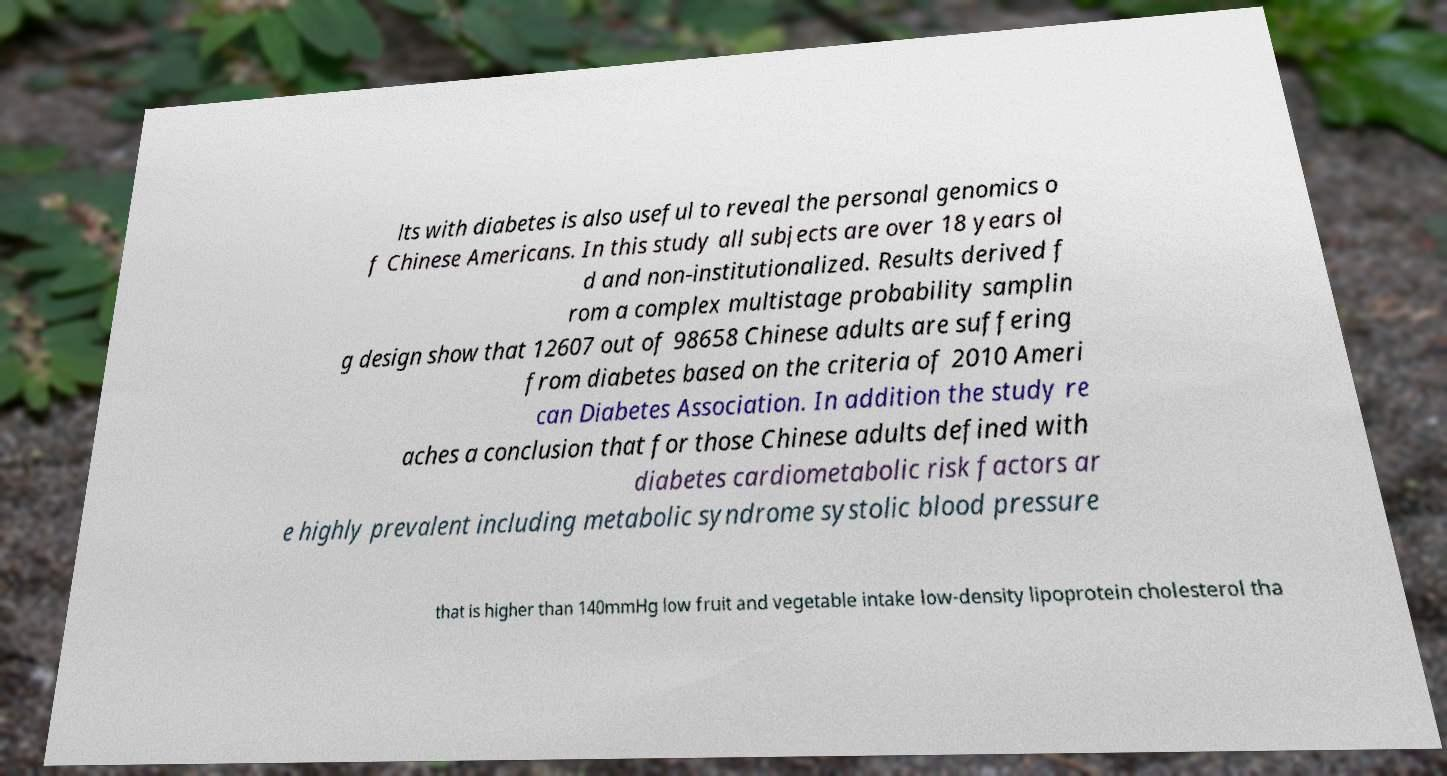Please identify and transcribe the text found in this image. lts with diabetes is also useful to reveal the personal genomics o f Chinese Americans. In this study all subjects are over 18 years ol d and non-institutionalized. Results derived f rom a complex multistage probability samplin g design show that 12607 out of 98658 Chinese adults are suffering from diabetes based on the criteria of 2010 Ameri can Diabetes Association. In addition the study re aches a conclusion that for those Chinese adults defined with diabetes cardiometabolic risk factors ar e highly prevalent including metabolic syndrome systolic blood pressure that is higher than 140mmHg low fruit and vegetable intake low-density lipoprotein cholesterol tha 